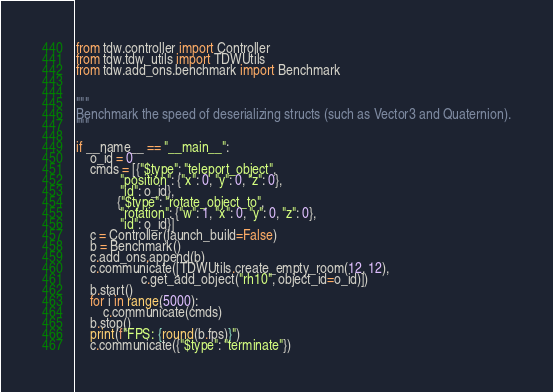Convert code to text. <code><loc_0><loc_0><loc_500><loc_500><_Python_>from tdw.controller import Controller
from tdw.tdw_utils import TDWUtils
from tdw.add_ons.benchmark import Benchmark


"""
Benchmark the speed of deserializing structs (such as Vector3 and Quaternion).
"""

if __name__ == "__main__":
    o_id = 0
    cmds = [{"$type": "teleport_object",
             "position": {"x": 0, "y": 0, "z": 0},
             "id": o_id},
            {"$type": "rotate_object_to",
             "rotation": {"w": 1, "x": 0, "y": 0, "z": 0},
             "id": o_id}]
    c = Controller(launch_build=False)
    b = Benchmark()
    c.add_ons.append(b)
    c.communicate([TDWUtils.create_empty_room(12, 12),
                   c.get_add_object("rh10", object_id=o_id)])
    b.start()
    for i in range(5000):
        c.communicate(cmds)
    b.stop()
    print(f"FPS: {round(b.fps)}")
    c.communicate({"$type": "terminate"})
</code> 